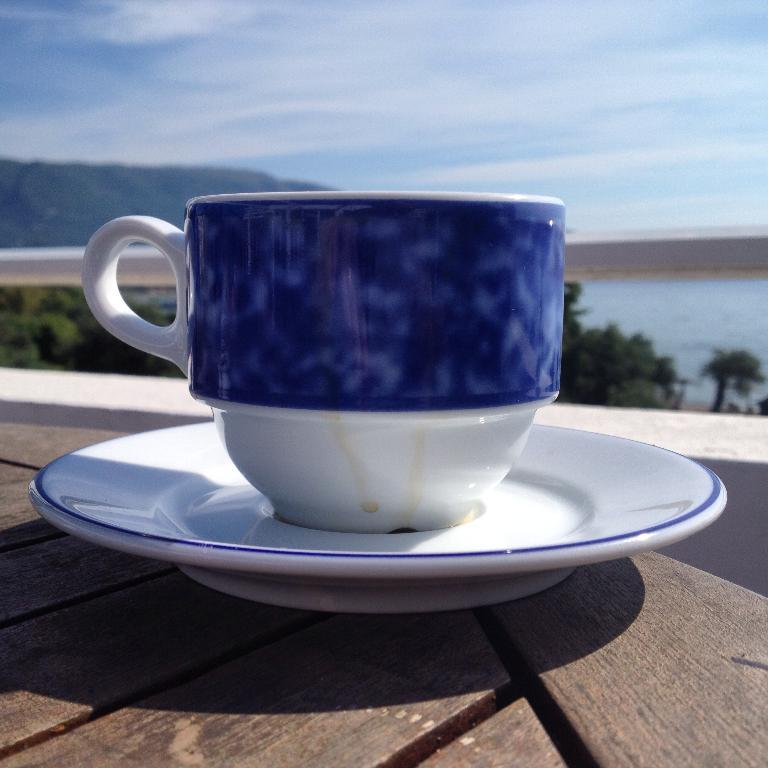What objects are placed on the table in the image? There is a cup and a saucer placed on a table in the image. What can be seen in the background of the image? In the background of the image, there is a fence, trees, hills, water, and the sky. How many elements are present in the background of the image? There are five elements present in the background: a fence, trees, hills, water, and the sky. What type of crate is being used to store the drawer in the image? There is no crate or drawer present in the image; it only features a cup and saucer on a table, along with the background elements. 